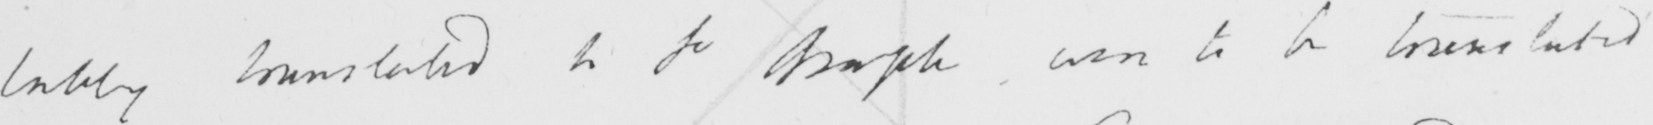Please transcribe the handwritten text in this image. lately translated to  <gap/>   <gap/>  was to be translated 